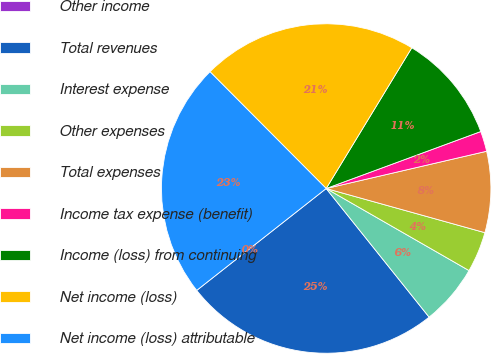<chart> <loc_0><loc_0><loc_500><loc_500><pie_chart><fcel>Other income<fcel>Total revenues<fcel>Interest expense<fcel>Other expenses<fcel>Total expenses<fcel>Income tax expense (benefit)<fcel>Income (loss) from continuing<fcel>Net income (loss)<fcel>Net income (loss) attributable<nl><fcel>0.0%<fcel>25.13%<fcel>5.96%<fcel>3.98%<fcel>7.95%<fcel>1.99%<fcel>10.68%<fcel>21.16%<fcel>23.15%<nl></chart> 